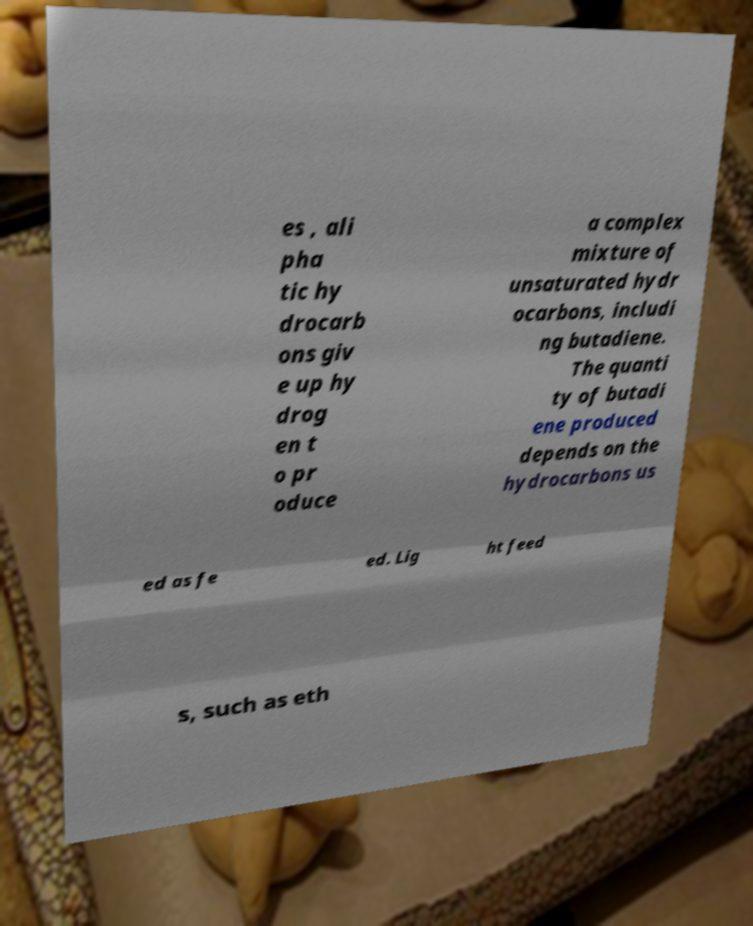For documentation purposes, I need the text within this image transcribed. Could you provide that? es , ali pha tic hy drocarb ons giv e up hy drog en t o pr oduce a complex mixture of unsaturated hydr ocarbons, includi ng butadiene. The quanti ty of butadi ene produced depends on the hydrocarbons us ed as fe ed. Lig ht feed s, such as eth 